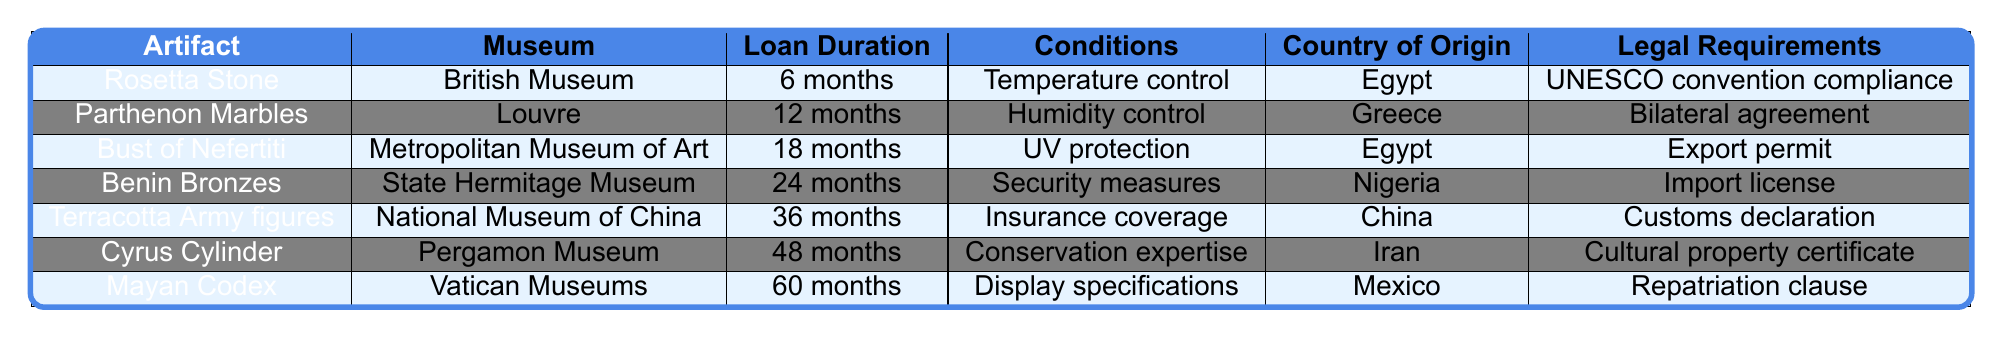What is the loan duration for the Rosetta Stone? The loan duration for the Rosetta Stone is listed in the table as 6 months.
Answer: 6 months Which museum has the longest loan duration artifact? The longest loan duration artifact is the Mayan Codex, which has a duration of 60 months, displayed at the Vatican Museums.
Answer: Vatican Museums Is temperature control a condition for any artifact's loan? Yes, temperature control is a condition listed for the Rosetta Stone's loan.
Answer: Yes How many artifacts have a loan duration of 24 months or longer? The artifacts with loan durations of 24 months or longer are Benin Bronzes, Terracotta Army figures, Cyrus Cylinder, and Mayan Codex, totaling 4 artifacts.
Answer: 4 artifacts What is the country of origin for the statue with the condition of UV protection? The Bust of Nefertiti has the condition of UV protection, and its country of origin is Egypt.
Answer: Egypt Are there any artifacts from China in the table? Yes, the Terracotta Army figures are from China according to the table.
Answer: Yes Which artifact has the most legal requirements listed? Each artifact has only one legal requirement listed, so none has more than another.
Answer: None What is the average loan duration of the artifacts listed? The loan durations are 6, 12, 18, 24, 36, 48, and 60 months. Their sum is 204 months and there are 7 artifacts, so the average is 204/7 ≈ 29.14 months.
Answer: 29.14 months Which artifact from Nigeria has security measures as its condition? The artifact from Nigeria with security measures as its condition is the Benin Bronzes.
Answer: Benin Bronzes Is there an artifact that requires a bilateral agreement for its loan? Yes, the Parthenon Marbles require a bilateral agreement as a legal requirement for their loan.
Answer: Yes 